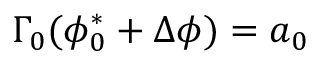Convert formula to latex. <formula><loc_0><loc_0><loc_500><loc_500>\Gamma _ { 0 } ( \phi _ { 0 } ^ { * } + \Delta \phi ) = a _ { 0 }</formula> 